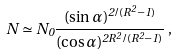<formula> <loc_0><loc_0><loc_500><loc_500>N \simeq N _ { 0 } \frac { ( \sin \alpha ) ^ { 2 / ( R ^ { 2 } - 1 ) } } { ( \cos \alpha ) ^ { 2 R ^ { 2 } / ( R ^ { 2 } - 1 ) } } \, ,</formula> 